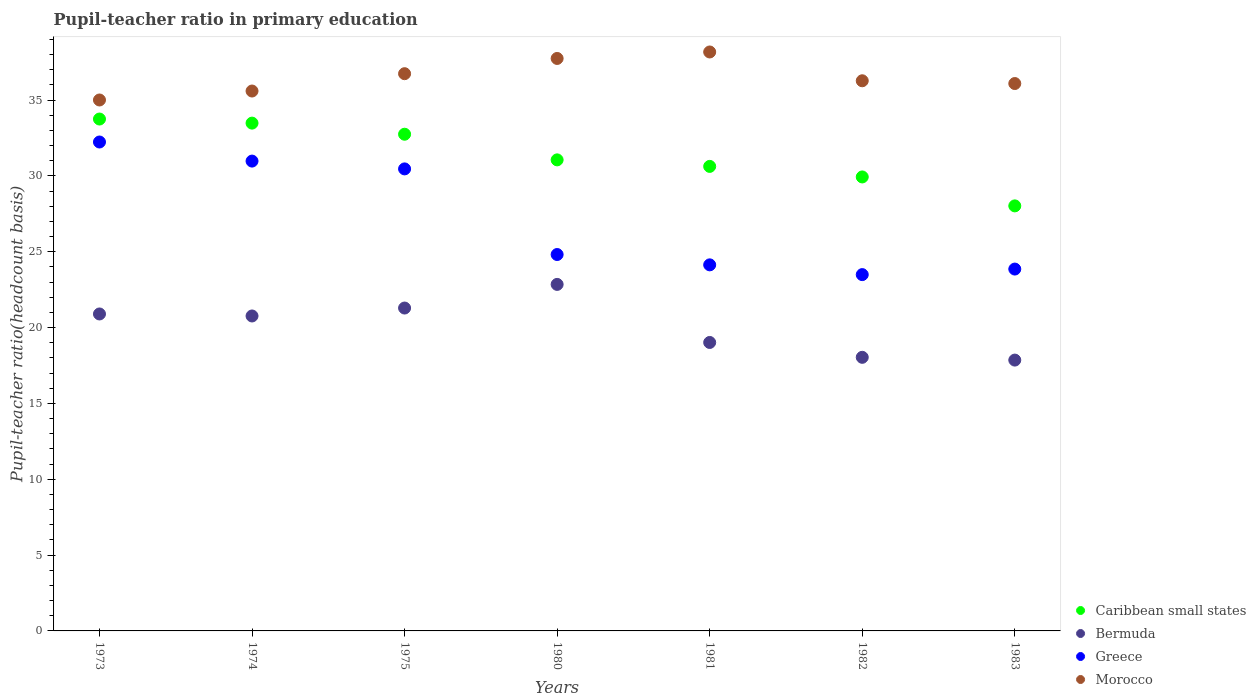What is the pupil-teacher ratio in primary education in Greece in 1981?
Keep it short and to the point. 24.14. Across all years, what is the maximum pupil-teacher ratio in primary education in Greece?
Your response must be concise. 32.24. Across all years, what is the minimum pupil-teacher ratio in primary education in Greece?
Your answer should be compact. 23.49. What is the total pupil-teacher ratio in primary education in Morocco in the graph?
Give a very brief answer. 255.63. What is the difference between the pupil-teacher ratio in primary education in Morocco in 1974 and that in 1982?
Your answer should be compact. -0.68. What is the difference between the pupil-teacher ratio in primary education in Greece in 1983 and the pupil-teacher ratio in primary education in Caribbean small states in 1980?
Make the answer very short. -7.2. What is the average pupil-teacher ratio in primary education in Greece per year?
Keep it short and to the point. 27.14. In the year 1981, what is the difference between the pupil-teacher ratio in primary education in Morocco and pupil-teacher ratio in primary education in Greece?
Give a very brief answer. 14.04. In how many years, is the pupil-teacher ratio in primary education in Greece greater than 20?
Offer a very short reply. 7. What is the ratio of the pupil-teacher ratio in primary education in Morocco in 1981 to that in 1982?
Ensure brevity in your answer.  1.05. What is the difference between the highest and the second highest pupil-teacher ratio in primary education in Greece?
Offer a very short reply. 1.26. What is the difference between the highest and the lowest pupil-teacher ratio in primary education in Morocco?
Your response must be concise. 3.17. In how many years, is the pupil-teacher ratio in primary education in Caribbean small states greater than the average pupil-teacher ratio in primary education in Caribbean small states taken over all years?
Offer a very short reply. 3. Is it the case that in every year, the sum of the pupil-teacher ratio in primary education in Morocco and pupil-teacher ratio in primary education in Caribbean small states  is greater than the sum of pupil-teacher ratio in primary education in Bermuda and pupil-teacher ratio in primary education in Greece?
Provide a succinct answer. Yes. Is it the case that in every year, the sum of the pupil-teacher ratio in primary education in Greece and pupil-teacher ratio in primary education in Bermuda  is greater than the pupil-teacher ratio in primary education in Caribbean small states?
Keep it short and to the point. Yes. Is the pupil-teacher ratio in primary education in Greece strictly greater than the pupil-teacher ratio in primary education in Bermuda over the years?
Ensure brevity in your answer.  Yes. How many years are there in the graph?
Ensure brevity in your answer.  7. Does the graph contain any zero values?
Keep it short and to the point. No. How many legend labels are there?
Your answer should be compact. 4. How are the legend labels stacked?
Your answer should be compact. Vertical. What is the title of the graph?
Provide a succinct answer. Pupil-teacher ratio in primary education. Does "Caribbean small states" appear as one of the legend labels in the graph?
Ensure brevity in your answer.  Yes. What is the label or title of the X-axis?
Give a very brief answer. Years. What is the label or title of the Y-axis?
Your answer should be very brief. Pupil-teacher ratio(headcount basis). What is the Pupil-teacher ratio(headcount basis) in Caribbean small states in 1973?
Give a very brief answer. 33.75. What is the Pupil-teacher ratio(headcount basis) of Bermuda in 1973?
Provide a succinct answer. 20.9. What is the Pupil-teacher ratio(headcount basis) of Greece in 1973?
Your answer should be compact. 32.24. What is the Pupil-teacher ratio(headcount basis) of Morocco in 1973?
Your answer should be very brief. 35.01. What is the Pupil-teacher ratio(headcount basis) in Caribbean small states in 1974?
Your answer should be very brief. 33.48. What is the Pupil-teacher ratio(headcount basis) of Bermuda in 1974?
Make the answer very short. 20.77. What is the Pupil-teacher ratio(headcount basis) of Greece in 1974?
Keep it short and to the point. 30.98. What is the Pupil-teacher ratio(headcount basis) of Morocco in 1974?
Offer a terse response. 35.6. What is the Pupil-teacher ratio(headcount basis) in Caribbean small states in 1975?
Your answer should be compact. 32.75. What is the Pupil-teacher ratio(headcount basis) of Bermuda in 1975?
Offer a very short reply. 21.29. What is the Pupil-teacher ratio(headcount basis) of Greece in 1975?
Give a very brief answer. 30.46. What is the Pupil-teacher ratio(headcount basis) of Morocco in 1975?
Give a very brief answer. 36.74. What is the Pupil-teacher ratio(headcount basis) in Caribbean small states in 1980?
Offer a very short reply. 31.06. What is the Pupil-teacher ratio(headcount basis) in Bermuda in 1980?
Give a very brief answer. 22.85. What is the Pupil-teacher ratio(headcount basis) of Greece in 1980?
Your answer should be compact. 24.82. What is the Pupil-teacher ratio(headcount basis) in Morocco in 1980?
Provide a short and direct response. 37.75. What is the Pupil-teacher ratio(headcount basis) in Caribbean small states in 1981?
Offer a very short reply. 30.63. What is the Pupil-teacher ratio(headcount basis) of Bermuda in 1981?
Provide a short and direct response. 19.02. What is the Pupil-teacher ratio(headcount basis) of Greece in 1981?
Provide a succinct answer. 24.14. What is the Pupil-teacher ratio(headcount basis) of Morocco in 1981?
Offer a very short reply. 38.17. What is the Pupil-teacher ratio(headcount basis) of Caribbean small states in 1982?
Provide a short and direct response. 29.93. What is the Pupil-teacher ratio(headcount basis) in Bermuda in 1982?
Your answer should be very brief. 18.04. What is the Pupil-teacher ratio(headcount basis) in Greece in 1982?
Ensure brevity in your answer.  23.49. What is the Pupil-teacher ratio(headcount basis) of Morocco in 1982?
Make the answer very short. 36.27. What is the Pupil-teacher ratio(headcount basis) in Caribbean small states in 1983?
Make the answer very short. 28.02. What is the Pupil-teacher ratio(headcount basis) of Bermuda in 1983?
Keep it short and to the point. 17.86. What is the Pupil-teacher ratio(headcount basis) of Greece in 1983?
Make the answer very short. 23.86. What is the Pupil-teacher ratio(headcount basis) of Morocco in 1983?
Provide a short and direct response. 36.09. Across all years, what is the maximum Pupil-teacher ratio(headcount basis) of Caribbean small states?
Your response must be concise. 33.75. Across all years, what is the maximum Pupil-teacher ratio(headcount basis) in Bermuda?
Give a very brief answer. 22.85. Across all years, what is the maximum Pupil-teacher ratio(headcount basis) of Greece?
Your response must be concise. 32.24. Across all years, what is the maximum Pupil-teacher ratio(headcount basis) of Morocco?
Offer a terse response. 38.17. Across all years, what is the minimum Pupil-teacher ratio(headcount basis) of Caribbean small states?
Your answer should be very brief. 28.02. Across all years, what is the minimum Pupil-teacher ratio(headcount basis) of Bermuda?
Provide a succinct answer. 17.86. Across all years, what is the minimum Pupil-teacher ratio(headcount basis) of Greece?
Give a very brief answer. 23.49. Across all years, what is the minimum Pupil-teacher ratio(headcount basis) of Morocco?
Offer a terse response. 35.01. What is the total Pupil-teacher ratio(headcount basis) of Caribbean small states in the graph?
Your answer should be very brief. 219.62. What is the total Pupil-teacher ratio(headcount basis) of Bermuda in the graph?
Provide a short and direct response. 140.72. What is the total Pupil-teacher ratio(headcount basis) of Greece in the graph?
Offer a terse response. 189.98. What is the total Pupil-teacher ratio(headcount basis) in Morocco in the graph?
Offer a very short reply. 255.63. What is the difference between the Pupil-teacher ratio(headcount basis) of Caribbean small states in 1973 and that in 1974?
Give a very brief answer. 0.27. What is the difference between the Pupil-teacher ratio(headcount basis) of Bermuda in 1973 and that in 1974?
Keep it short and to the point. 0.13. What is the difference between the Pupil-teacher ratio(headcount basis) of Greece in 1973 and that in 1974?
Provide a succinct answer. 1.26. What is the difference between the Pupil-teacher ratio(headcount basis) in Morocco in 1973 and that in 1974?
Ensure brevity in your answer.  -0.59. What is the difference between the Pupil-teacher ratio(headcount basis) in Caribbean small states in 1973 and that in 1975?
Keep it short and to the point. 1. What is the difference between the Pupil-teacher ratio(headcount basis) in Bermuda in 1973 and that in 1975?
Your answer should be compact. -0.39. What is the difference between the Pupil-teacher ratio(headcount basis) of Greece in 1973 and that in 1975?
Your answer should be compact. 1.77. What is the difference between the Pupil-teacher ratio(headcount basis) of Morocco in 1973 and that in 1975?
Provide a succinct answer. -1.73. What is the difference between the Pupil-teacher ratio(headcount basis) of Caribbean small states in 1973 and that in 1980?
Provide a succinct answer. 2.69. What is the difference between the Pupil-teacher ratio(headcount basis) of Bermuda in 1973 and that in 1980?
Provide a short and direct response. -1.95. What is the difference between the Pupil-teacher ratio(headcount basis) in Greece in 1973 and that in 1980?
Give a very brief answer. 7.42. What is the difference between the Pupil-teacher ratio(headcount basis) of Morocco in 1973 and that in 1980?
Give a very brief answer. -2.74. What is the difference between the Pupil-teacher ratio(headcount basis) in Caribbean small states in 1973 and that in 1981?
Make the answer very short. 3.12. What is the difference between the Pupil-teacher ratio(headcount basis) of Bermuda in 1973 and that in 1981?
Make the answer very short. 1.88. What is the difference between the Pupil-teacher ratio(headcount basis) in Greece in 1973 and that in 1981?
Ensure brevity in your answer.  8.1. What is the difference between the Pupil-teacher ratio(headcount basis) of Morocco in 1973 and that in 1981?
Provide a succinct answer. -3.17. What is the difference between the Pupil-teacher ratio(headcount basis) of Caribbean small states in 1973 and that in 1982?
Provide a succinct answer. 3.82. What is the difference between the Pupil-teacher ratio(headcount basis) in Bermuda in 1973 and that in 1982?
Your response must be concise. 2.86. What is the difference between the Pupil-teacher ratio(headcount basis) in Greece in 1973 and that in 1982?
Provide a short and direct response. 8.74. What is the difference between the Pupil-teacher ratio(headcount basis) in Morocco in 1973 and that in 1982?
Keep it short and to the point. -1.27. What is the difference between the Pupil-teacher ratio(headcount basis) of Caribbean small states in 1973 and that in 1983?
Your answer should be compact. 5.73. What is the difference between the Pupil-teacher ratio(headcount basis) of Bermuda in 1973 and that in 1983?
Make the answer very short. 3.04. What is the difference between the Pupil-teacher ratio(headcount basis) of Greece in 1973 and that in 1983?
Provide a short and direct response. 8.38. What is the difference between the Pupil-teacher ratio(headcount basis) in Morocco in 1973 and that in 1983?
Give a very brief answer. -1.08. What is the difference between the Pupil-teacher ratio(headcount basis) in Caribbean small states in 1974 and that in 1975?
Ensure brevity in your answer.  0.73. What is the difference between the Pupil-teacher ratio(headcount basis) in Bermuda in 1974 and that in 1975?
Ensure brevity in your answer.  -0.52. What is the difference between the Pupil-teacher ratio(headcount basis) in Greece in 1974 and that in 1975?
Make the answer very short. 0.51. What is the difference between the Pupil-teacher ratio(headcount basis) of Morocco in 1974 and that in 1975?
Keep it short and to the point. -1.14. What is the difference between the Pupil-teacher ratio(headcount basis) of Caribbean small states in 1974 and that in 1980?
Your answer should be very brief. 2.42. What is the difference between the Pupil-teacher ratio(headcount basis) in Bermuda in 1974 and that in 1980?
Provide a short and direct response. -2.08. What is the difference between the Pupil-teacher ratio(headcount basis) of Greece in 1974 and that in 1980?
Your answer should be very brief. 6.16. What is the difference between the Pupil-teacher ratio(headcount basis) of Morocco in 1974 and that in 1980?
Ensure brevity in your answer.  -2.15. What is the difference between the Pupil-teacher ratio(headcount basis) of Caribbean small states in 1974 and that in 1981?
Ensure brevity in your answer.  2.85. What is the difference between the Pupil-teacher ratio(headcount basis) of Bermuda in 1974 and that in 1981?
Provide a short and direct response. 1.75. What is the difference between the Pupil-teacher ratio(headcount basis) of Greece in 1974 and that in 1981?
Your answer should be very brief. 6.84. What is the difference between the Pupil-teacher ratio(headcount basis) in Morocco in 1974 and that in 1981?
Keep it short and to the point. -2.57. What is the difference between the Pupil-teacher ratio(headcount basis) of Caribbean small states in 1974 and that in 1982?
Your response must be concise. 3.55. What is the difference between the Pupil-teacher ratio(headcount basis) of Bermuda in 1974 and that in 1982?
Provide a short and direct response. 2.73. What is the difference between the Pupil-teacher ratio(headcount basis) of Greece in 1974 and that in 1982?
Give a very brief answer. 7.48. What is the difference between the Pupil-teacher ratio(headcount basis) in Morocco in 1974 and that in 1982?
Your response must be concise. -0.68. What is the difference between the Pupil-teacher ratio(headcount basis) of Caribbean small states in 1974 and that in 1983?
Your response must be concise. 5.46. What is the difference between the Pupil-teacher ratio(headcount basis) of Bermuda in 1974 and that in 1983?
Offer a terse response. 2.91. What is the difference between the Pupil-teacher ratio(headcount basis) of Greece in 1974 and that in 1983?
Provide a short and direct response. 7.12. What is the difference between the Pupil-teacher ratio(headcount basis) of Morocco in 1974 and that in 1983?
Make the answer very short. -0.49. What is the difference between the Pupil-teacher ratio(headcount basis) of Caribbean small states in 1975 and that in 1980?
Make the answer very short. 1.69. What is the difference between the Pupil-teacher ratio(headcount basis) of Bermuda in 1975 and that in 1980?
Your response must be concise. -1.56. What is the difference between the Pupil-teacher ratio(headcount basis) of Greece in 1975 and that in 1980?
Give a very brief answer. 5.65. What is the difference between the Pupil-teacher ratio(headcount basis) in Morocco in 1975 and that in 1980?
Provide a succinct answer. -1. What is the difference between the Pupil-teacher ratio(headcount basis) of Caribbean small states in 1975 and that in 1981?
Ensure brevity in your answer.  2.12. What is the difference between the Pupil-teacher ratio(headcount basis) of Bermuda in 1975 and that in 1981?
Provide a succinct answer. 2.27. What is the difference between the Pupil-teacher ratio(headcount basis) of Greece in 1975 and that in 1981?
Your answer should be compact. 6.33. What is the difference between the Pupil-teacher ratio(headcount basis) in Morocco in 1975 and that in 1981?
Offer a very short reply. -1.43. What is the difference between the Pupil-teacher ratio(headcount basis) of Caribbean small states in 1975 and that in 1982?
Offer a terse response. 2.82. What is the difference between the Pupil-teacher ratio(headcount basis) in Bermuda in 1975 and that in 1982?
Your answer should be very brief. 3.25. What is the difference between the Pupil-teacher ratio(headcount basis) in Greece in 1975 and that in 1982?
Provide a short and direct response. 6.97. What is the difference between the Pupil-teacher ratio(headcount basis) of Morocco in 1975 and that in 1982?
Offer a terse response. 0.47. What is the difference between the Pupil-teacher ratio(headcount basis) in Caribbean small states in 1975 and that in 1983?
Offer a very short reply. 4.72. What is the difference between the Pupil-teacher ratio(headcount basis) in Bermuda in 1975 and that in 1983?
Offer a very short reply. 3.43. What is the difference between the Pupil-teacher ratio(headcount basis) in Greece in 1975 and that in 1983?
Give a very brief answer. 6.6. What is the difference between the Pupil-teacher ratio(headcount basis) in Morocco in 1975 and that in 1983?
Provide a short and direct response. 0.65. What is the difference between the Pupil-teacher ratio(headcount basis) in Caribbean small states in 1980 and that in 1981?
Ensure brevity in your answer.  0.43. What is the difference between the Pupil-teacher ratio(headcount basis) of Bermuda in 1980 and that in 1981?
Give a very brief answer. 3.83. What is the difference between the Pupil-teacher ratio(headcount basis) in Greece in 1980 and that in 1981?
Provide a short and direct response. 0.68. What is the difference between the Pupil-teacher ratio(headcount basis) of Morocco in 1980 and that in 1981?
Your answer should be very brief. -0.43. What is the difference between the Pupil-teacher ratio(headcount basis) of Caribbean small states in 1980 and that in 1982?
Give a very brief answer. 1.13. What is the difference between the Pupil-teacher ratio(headcount basis) in Bermuda in 1980 and that in 1982?
Give a very brief answer. 4.81. What is the difference between the Pupil-teacher ratio(headcount basis) in Greece in 1980 and that in 1982?
Provide a succinct answer. 1.32. What is the difference between the Pupil-teacher ratio(headcount basis) in Morocco in 1980 and that in 1982?
Offer a very short reply. 1.47. What is the difference between the Pupil-teacher ratio(headcount basis) of Caribbean small states in 1980 and that in 1983?
Offer a terse response. 3.03. What is the difference between the Pupil-teacher ratio(headcount basis) of Bermuda in 1980 and that in 1983?
Ensure brevity in your answer.  4.99. What is the difference between the Pupil-teacher ratio(headcount basis) of Greece in 1980 and that in 1983?
Provide a short and direct response. 0.96. What is the difference between the Pupil-teacher ratio(headcount basis) in Morocco in 1980 and that in 1983?
Offer a very short reply. 1.65. What is the difference between the Pupil-teacher ratio(headcount basis) in Caribbean small states in 1981 and that in 1982?
Your answer should be compact. 0.7. What is the difference between the Pupil-teacher ratio(headcount basis) of Bermuda in 1981 and that in 1982?
Your answer should be very brief. 0.98. What is the difference between the Pupil-teacher ratio(headcount basis) in Greece in 1981 and that in 1982?
Make the answer very short. 0.64. What is the difference between the Pupil-teacher ratio(headcount basis) in Morocco in 1981 and that in 1982?
Provide a short and direct response. 1.9. What is the difference between the Pupil-teacher ratio(headcount basis) of Caribbean small states in 1981 and that in 1983?
Ensure brevity in your answer.  2.6. What is the difference between the Pupil-teacher ratio(headcount basis) of Bermuda in 1981 and that in 1983?
Provide a succinct answer. 1.16. What is the difference between the Pupil-teacher ratio(headcount basis) of Greece in 1981 and that in 1983?
Your answer should be compact. 0.28. What is the difference between the Pupil-teacher ratio(headcount basis) in Morocco in 1981 and that in 1983?
Your response must be concise. 2.08. What is the difference between the Pupil-teacher ratio(headcount basis) in Caribbean small states in 1982 and that in 1983?
Offer a very short reply. 1.91. What is the difference between the Pupil-teacher ratio(headcount basis) in Bermuda in 1982 and that in 1983?
Offer a terse response. 0.18. What is the difference between the Pupil-teacher ratio(headcount basis) of Greece in 1982 and that in 1983?
Keep it short and to the point. -0.37. What is the difference between the Pupil-teacher ratio(headcount basis) of Morocco in 1982 and that in 1983?
Your answer should be compact. 0.18. What is the difference between the Pupil-teacher ratio(headcount basis) of Caribbean small states in 1973 and the Pupil-teacher ratio(headcount basis) of Bermuda in 1974?
Offer a very short reply. 12.98. What is the difference between the Pupil-teacher ratio(headcount basis) in Caribbean small states in 1973 and the Pupil-teacher ratio(headcount basis) in Greece in 1974?
Provide a succinct answer. 2.77. What is the difference between the Pupil-teacher ratio(headcount basis) in Caribbean small states in 1973 and the Pupil-teacher ratio(headcount basis) in Morocco in 1974?
Ensure brevity in your answer.  -1.85. What is the difference between the Pupil-teacher ratio(headcount basis) of Bermuda in 1973 and the Pupil-teacher ratio(headcount basis) of Greece in 1974?
Your response must be concise. -10.08. What is the difference between the Pupil-teacher ratio(headcount basis) in Bermuda in 1973 and the Pupil-teacher ratio(headcount basis) in Morocco in 1974?
Provide a succinct answer. -14.7. What is the difference between the Pupil-teacher ratio(headcount basis) of Greece in 1973 and the Pupil-teacher ratio(headcount basis) of Morocco in 1974?
Your response must be concise. -3.36. What is the difference between the Pupil-teacher ratio(headcount basis) in Caribbean small states in 1973 and the Pupil-teacher ratio(headcount basis) in Bermuda in 1975?
Offer a terse response. 12.46. What is the difference between the Pupil-teacher ratio(headcount basis) in Caribbean small states in 1973 and the Pupil-teacher ratio(headcount basis) in Greece in 1975?
Make the answer very short. 3.29. What is the difference between the Pupil-teacher ratio(headcount basis) of Caribbean small states in 1973 and the Pupil-teacher ratio(headcount basis) of Morocco in 1975?
Give a very brief answer. -2.99. What is the difference between the Pupil-teacher ratio(headcount basis) in Bermuda in 1973 and the Pupil-teacher ratio(headcount basis) in Greece in 1975?
Your answer should be very brief. -9.56. What is the difference between the Pupil-teacher ratio(headcount basis) in Bermuda in 1973 and the Pupil-teacher ratio(headcount basis) in Morocco in 1975?
Offer a very short reply. -15.84. What is the difference between the Pupil-teacher ratio(headcount basis) in Greece in 1973 and the Pupil-teacher ratio(headcount basis) in Morocco in 1975?
Provide a short and direct response. -4.5. What is the difference between the Pupil-teacher ratio(headcount basis) of Caribbean small states in 1973 and the Pupil-teacher ratio(headcount basis) of Bermuda in 1980?
Keep it short and to the point. 10.9. What is the difference between the Pupil-teacher ratio(headcount basis) of Caribbean small states in 1973 and the Pupil-teacher ratio(headcount basis) of Greece in 1980?
Your answer should be compact. 8.93. What is the difference between the Pupil-teacher ratio(headcount basis) of Caribbean small states in 1973 and the Pupil-teacher ratio(headcount basis) of Morocco in 1980?
Your answer should be compact. -3.99. What is the difference between the Pupil-teacher ratio(headcount basis) of Bermuda in 1973 and the Pupil-teacher ratio(headcount basis) of Greece in 1980?
Offer a terse response. -3.92. What is the difference between the Pupil-teacher ratio(headcount basis) in Bermuda in 1973 and the Pupil-teacher ratio(headcount basis) in Morocco in 1980?
Ensure brevity in your answer.  -16.85. What is the difference between the Pupil-teacher ratio(headcount basis) in Greece in 1973 and the Pupil-teacher ratio(headcount basis) in Morocco in 1980?
Make the answer very short. -5.51. What is the difference between the Pupil-teacher ratio(headcount basis) of Caribbean small states in 1973 and the Pupil-teacher ratio(headcount basis) of Bermuda in 1981?
Keep it short and to the point. 14.73. What is the difference between the Pupil-teacher ratio(headcount basis) of Caribbean small states in 1973 and the Pupil-teacher ratio(headcount basis) of Greece in 1981?
Keep it short and to the point. 9.61. What is the difference between the Pupil-teacher ratio(headcount basis) of Caribbean small states in 1973 and the Pupil-teacher ratio(headcount basis) of Morocco in 1981?
Your answer should be compact. -4.42. What is the difference between the Pupil-teacher ratio(headcount basis) in Bermuda in 1973 and the Pupil-teacher ratio(headcount basis) in Greece in 1981?
Your response must be concise. -3.24. What is the difference between the Pupil-teacher ratio(headcount basis) of Bermuda in 1973 and the Pupil-teacher ratio(headcount basis) of Morocco in 1981?
Provide a succinct answer. -17.27. What is the difference between the Pupil-teacher ratio(headcount basis) of Greece in 1973 and the Pupil-teacher ratio(headcount basis) of Morocco in 1981?
Provide a succinct answer. -5.94. What is the difference between the Pupil-teacher ratio(headcount basis) in Caribbean small states in 1973 and the Pupil-teacher ratio(headcount basis) in Bermuda in 1982?
Make the answer very short. 15.71. What is the difference between the Pupil-teacher ratio(headcount basis) in Caribbean small states in 1973 and the Pupil-teacher ratio(headcount basis) in Greece in 1982?
Provide a succinct answer. 10.26. What is the difference between the Pupil-teacher ratio(headcount basis) in Caribbean small states in 1973 and the Pupil-teacher ratio(headcount basis) in Morocco in 1982?
Give a very brief answer. -2.52. What is the difference between the Pupil-teacher ratio(headcount basis) in Bermuda in 1973 and the Pupil-teacher ratio(headcount basis) in Greece in 1982?
Provide a succinct answer. -2.59. What is the difference between the Pupil-teacher ratio(headcount basis) of Bermuda in 1973 and the Pupil-teacher ratio(headcount basis) of Morocco in 1982?
Offer a terse response. -15.37. What is the difference between the Pupil-teacher ratio(headcount basis) of Greece in 1973 and the Pupil-teacher ratio(headcount basis) of Morocco in 1982?
Keep it short and to the point. -4.04. What is the difference between the Pupil-teacher ratio(headcount basis) in Caribbean small states in 1973 and the Pupil-teacher ratio(headcount basis) in Bermuda in 1983?
Your answer should be very brief. 15.89. What is the difference between the Pupil-teacher ratio(headcount basis) in Caribbean small states in 1973 and the Pupil-teacher ratio(headcount basis) in Greece in 1983?
Provide a short and direct response. 9.89. What is the difference between the Pupil-teacher ratio(headcount basis) of Caribbean small states in 1973 and the Pupil-teacher ratio(headcount basis) of Morocco in 1983?
Ensure brevity in your answer.  -2.34. What is the difference between the Pupil-teacher ratio(headcount basis) of Bermuda in 1973 and the Pupil-teacher ratio(headcount basis) of Greece in 1983?
Offer a terse response. -2.96. What is the difference between the Pupil-teacher ratio(headcount basis) of Bermuda in 1973 and the Pupil-teacher ratio(headcount basis) of Morocco in 1983?
Make the answer very short. -15.19. What is the difference between the Pupil-teacher ratio(headcount basis) of Greece in 1973 and the Pupil-teacher ratio(headcount basis) of Morocco in 1983?
Provide a succinct answer. -3.86. What is the difference between the Pupil-teacher ratio(headcount basis) in Caribbean small states in 1974 and the Pupil-teacher ratio(headcount basis) in Bermuda in 1975?
Give a very brief answer. 12.19. What is the difference between the Pupil-teacher ratio(headcount basis) of Caribbean small states in 1974 and the Pupil-teacher ratio(headcount basis) of Greece in 1975?
Provide a short and direct response. 3.02. What is the difference between the Pupil-teacher ratio(headcount basis) of Caribbean small states in 1974 and the Pupil-teacher ratio(headcount basis) of Morocco in 1975?
Make the answer very short. -3.26. What is the difference between the Pupil-teacher ratio(headcount basis) of Bermuda in 1974 and the Pupil-teacher ratio(headcount basis) of Greece in 1975?
Your answer should be very brief. -9.7. What is the difference between the Pupil-teacher ratio(headcount basis) of Bermuda in 1974 and the Pupil-teacher ratio(headcount basis) of Morocco in 1975?
Your answer should be compact. -15.97. What is the difference between the Pupil-teacher ratio(headcount basis) of Greece in 1974 and the Pupil-teacher ratio(headcount basis) of Morocco in 1975?
Your response must be concise. -5.76. What is the difference between the Pupil-teacher ratio(headcount basis) of Caribbean small states in 1974 and the Pupil-teacher ratio(headcount basis) of Bermuda in 1980?
Make the answer very short. 10.63. What is the difference between the Pupil-teacher ratio(headcount basis) in Caribbean small states in 1974 and the Pupil-teacher ratio(headcount basis) in Greece in 1980?
Give a very brief answer. 8.66. What is the difference between the Pupil-teacher ratio(headcount basis) in Caribbean small states in 1974 and the Pupil-teacher ratio(headcount basis) in Morocco in 1980?
Make the answer very short. -4.26. What is the difference between the Pupil-teacher ratio(headcount basis) of Bermuda in 1974 and the Pupil-teacher ratio(headcount basis) of Greece in 1980?
Provide a short and direct response. -4.05. What is the difference between the Pupil-teacher ratio(headcount basis) in Bermuda in 1974 and the Pupil-teacher ratio(headcount basis) in Morocco in 1980?
Your response must be concise. -16.98. What is the difference between the Pupil-teacher ratio(headcount basis) in Greece in 1974 and the Pupil-teacher ratio(headcount basis) in Morocco in 1980?
Your response must be concise. -6.77. What is the difference between the Pupil-teacher ratio(headcount basis) of Caribbean small states in 1974 and the Pupil-teacher ratio(headcount basis) of Bermuda in 1981?
Provide a short and direct response. 14.46. What is the difference between the Pupil-teacher ratio(headcount basis) in Caribbean small states in 1974 and the Pupil-teacher ratio(headcount basis) in Greece in 1981?
Your answer should be very brief. 9.35. What is the difference between the Pupil-teacher ratio(headcount basis) of Caribbean small states in 1974 and the Pupil-teacher ratio(headcount basis) of Morocco in 1981?
Ensure brevity in your answer.  -4.69. What is the difference between the Pupil-teacher ratio(headcount basis) in Bermuda in 1974 and the Pupil-teacher ratio(headcount basis) in Greece in 1981?
Your response must be concise. -3.37. What is the difference between the Pupil-teacher ratio(headcount basis) of Bermuda in 1974 and the Pupil-teacher ratio(headcount basis) of Morocco in 1981?
Your answer should be compact. -17.41. What is the difference between the Pupil-teacher ratio(headcount basis) of Greece in 1974 and the Pupil-teacher ratio(headcount basis) of Morocco in 1981?
Offer a very short reply. -7.19. What is the difference between the Pupil-teacher ratio(headcount basis) of Caribbean small states in 1974 and the Pupil-teacher ratio(headcount basis) of Bermuda in 1982?
Your response must be concise. 15.44. What is the difference between the Pupil-teacher ratio(headcount basis) of Caribbean small states in 1974 and the Pupil-teacher ratio(headcount basis) of Greece in 1982?
Offer a terse response. 9.99. What is the difference between the Pupil-teacher ratio(headcount basis) in Caribbean small states in 1974 and the Pupil-teacher ratio(headcount basis) in Morocco in 1982?
Offer a terse response. -2.79. What is the difference between the Pupil-teacher ratio(headcount basis) of Bermuda in 1974 and the Pupil-teacher ratio(headcount basis) of Greece in 1982?
Give a very brief answer. -2.73. What is the difference between the Pupil-teacher ratio(headcount basis) of Bermuda in 1974 and the Pupil-teacher ratio(headcount basis) of Morocco in 1982?
Your response must be concise. -15.51. What is the difference between the Pupil-teacher ratio(headcount basis) of Greece in 1974 and the Pupil-teacher ratio(headcount basis) of Morocco in 1982?
Keep it short and to the point. -5.3. What is the difference between the Pupil-teacher ratio(headcount basis) of Caribbean small states in 1974 and the Pupil-teacher ratio(headcount basis) of Bermuda in 1983?
Make the answer very short. 15.62. What is the difference between the Pupil-teacher ratio(headcount basis) in Caribbean small states in 1974 and the Pupil-teacher ratio(headcount basis) in Greece in 1983?
Your answer should be compact. 9.62. What is the difference between the Pupil-teacher ratio(headcount basis) in Caribbean small states in 1974 and the Pupil-teacher ratio(headcount basis) in Morocco in 1983?
Offer a terse response. -2.61. What is the difference between the Pupil-teacher ratio(headcount basis) in Bermuda in 1974 and the Pupil-teacher ratio(headcount basis) in Greece in 1983?
Your answer should be compact. -3.09. What is the difference between the Pupil-teacher ratio(headcount basis) in Bermuda in 1974 and the Pupil-teacher ratio(headcount basis) in Morocco in 1983?
Make the answer very short. -15.33. What is the difference between the Pupil-teacher ratio(headcount basis) in Greece in 1974 and the Pupil-teacher ratio(headcount basis) in Morocco in 1983?
Your answer should be compact. -5.11. What is the difference between the Pupil-teacher ratio(headcount basis) of Caribbean small states in 1975 and the Pupil-teacher ratio(headcount basis) of Bermuda in 1980?
Offer a very short reply. 9.9. What is the difference between the Pupil-teacher ratio(headcount basis) in Caribbean small states in 1975 and the Pupil-teacher ratio(headcount basis) in Greece in 1980?
Provide a short and direct response. 7.93. What is the difference between the Pupil-teacher ratio(headcount basis) of Caribbean small states in 1975 and the Pupil-teacher ratio(headcount basis) of Morocco in 1980?
Keep it short and to the point. -5. What is the difference between the Pupil-teacher ratio(headcount basis) in Bermuda in 1975 and the Pupil-teacher ratio(headcount basis) in Greece in 1980?
Your answer should be compact. -3.53. What is the difference between the Pupil-teacher ratio(headcount basis) in Bermuda in 1975 and the Pupil-teacher ratio(headcount basis) in Morocco in 1980?
Your response must be concise. -16.46. What is the difference between the Pupil-teacher ratio(headcount basis) of Greece in 1975 and the Pupil-teacher ratio(headcount basis) of Morocco in 1980?
Your answer should be compact. -7.28. What is the difference between the Pupil-teacher ratio(headcount basis) of Caribbean small states in 1975 and the Pupil-teacher ratio(headcount basis) of Bermuda in 1981?
Make the answer very short. 13.73. What is the difference between the Pupil-teacher ratio(headcount basis) in Caribbean small states in 1975 and the Pupil-teacher ratio(headcount basis) in Greece in 1981?
Make the answer very short. 8.61. What is the difference between the Pupil-teacher ratio(headcount basis) in Caribbean small states in 1975 and the Pupil-teacher ratio(headcount basis) in Morocco in 1981?
Provide a succinct answer. -5.42. What is the difference between the Pupil-teacher ratio(headcount basis) in Bermuda in 1975 and the Pupil-teacher ratio(headcount basis) in Greece in 1981?
Offer a terse response. -2.85. What is the difference between the Pupil-teacher ratio(headcount basis) in Bermuda in 1975 and the Pupil-teacher ratio(headcount basis) in Morocco in 1981?
Make the answer very short. -16.88. What is the difference between the Pupil-teacher ratio(headcount basis) of Greece in 1975 and the Pupil-teacher ratio(headcount basis) of Morocco in 1981?
Your answer should be very brief. -7.71. What is the difference between the Pupil-teacher ratio(headcount basis) in Caribbean small states in 1975 and the Pupil-teacher ratio(headcount basis) in Bermuda in 1982?
Offer a terse response. 14.71. What is the difference between the Pupil-teacher ratio(headcount basis) of Caribbean small states in 1975 and the Pupil-teacher ratio(headcount basis) of Greece in 1982?
Your response must be concise. 9.26. What is the difference between the Pupil-teacher ratio(headcount basis) in Caribbean small states in 1975 and the Pupil-teacher ratio(headcount basis) in Morocco in 1982?
Ensure brevity in your answer.  -3.52. What is the difference between the Pupil-teacher ratio(headcount basis) in Bermuda in 1975 and the Pupil-teacher ratio(headcount basis) in Greece in 1982?
Offer a terse response. -2.2. What is the difference between the Pupil-teacher ratio(headcount basis) of Bermuda in 1975 and the Pupil-teacher ratio(headcount basis) of Morocco in 1982?
Provide a short and direct response. -14.98. What is the difference between the Pupil-teacher ratio(headcount basis) in Greece in 1975 and the Pupil-teacher ratio(headcount basis) in Morocco in 1982?
Make the answer very short. -5.81. What is the difference between the Pupil-teacher ratio(headcount basis) in Caribbean small states in 1975 and the Pupil-teacher ratio(headcount basis) in Bermuda in 1983?
Provide a succinct answer. 14.89. What is the difference between the Pupil-teacher ratio(headcount basis) of Caribbean small states in 1975 and the Pupil-teacher ratio(headcount basis) of Greece in 1983?
Your answer should be very brief. 8.89. What is the difference between the Pupil-teacher ratio(headcount basis) in Caribbean small states in 1975 and the Pupil-teacher ratio(headcount basis) in Morocco in 1983?
Provide a succinct answer. -3.34. What is the difference between the Pupil-teacher ratio(headcount basis) in Bermuda in 1975 and the Pupil-teacher ratio(headcount basis) in Greece in 1983?
Offer a terse response. -2.57. What is the difference between the Pupil-teacher ratio(headcount basis) of Bermuda in 1975 and the Pupil-teacher ratio(headcount basis) of Morocco in 1983?
Your answer should be very brief. -14.8. What is the difference between the Pupil-teacher ratio(headcount basis) of Greece in 1975 and the Pupil-teacher ratio(headcount basis) of Morocco in 1983?
Keep it short and to the point. -5.63. What is the difference between the Pupil-teacher ratio(headcount basis) in Caribbean small states in 1980 and the Pupil-teacher ratio(headcount basis) in Bermuda in 1981?
Provide a succinct answer. 12.04. What is the difference between the Pupil-teacher ratio(headcount basis) in Caribbean small states in 1980 and the Pupil-teacher ratio(headcount basis) in Greece in 1981?
Your response must be concise. 6.92. What is the difference between the Pupil-teacher ratio(headcount basis) in Caribbean small states in 1980 and the Pupil-teacher ratio(headcount basis) in Morocco in 1981?
Keep it short and to the point. -7.11. What is the difference between the Pupil-teacher ratio(headcount basis) of Bermuda in 1980 and the Pupil-teacher ratio(headcount basis) of Greece in 1981?
Provide a short and direct response. -1.29. What is the difference between the Pupil-teacher ratio(headcount basis) of Bermuda in 1980 and the Pupil-teacher ratio(headcount basis) of Morocco in 1981?
Offer a very short reply. -15.32. What is the difference between the Pupil-teacher ratio(headcount basis) in Greece in 1980 and the Pupil-teacher ratio(headcount basis) in Morocco in 1981?
Give a very brief answer. -13.35. What is the difference between the Pupil-teacher ratio(headcount basis) of Caribbean small states in 1980 and the Pupil-teacher ratio(headcount basis) of Bermuda in 1982?
Your answer should be compact. 13.02. What is the difference between the Pupil-teacher ratio(headcount basis) of Caribbean small states in 1980 and the Pupil-teacher ratio(headcount basis) of Greece in 1982?
Your answer should be compact. 7.57. What is the difference between the Pupil-teacher ratio(headcount basis) of Caribbean small states in 1980 and the Pupil-teacher ratio(headcount basis) of Morocco in 1982?
Ensure brevity in your answer.  -5.22. What is the difference between the Pupil-teacher ratio(headcount basis) of Bermuda in 1980 and the Pupil-teacher ratio(headcount basis) of Greece in 1982?
Make the answer very short. -0.65. What is the difference between the Pupil-teacher ratio(headcount basis) in Bermuda in 1980 and the Pupil-teacher ratio(headcount basis) in Morocco in 1982?
Ensure brevity in your answer.  -13.43. What is the difference between the Pupil-teacher ratio(headcount basis) of Greece in 1980 and the Pupil-teacher ratio(headcount basis) of Morocco in 1982?
Ensure brevity in your answer.  -11.46. What is the difference between the Pupil-teacher ratio(headcount basis) in Caribbean small states in 1980 and the Pupil-teacher ratio(headcount basis) in Bermuda in 1983?
Ensure brevity in your answer.  13.2. What is the difference between the Pupil-teacher ratio(headcount basis) in Caribbean small states in 1980 and the Pupil-teacher ratio(headcount basis) in Greece in 1983?
Ensure brevity in your answer.  7.2. What is the difference between the Pupil-teacher ratio(headcount basis) of Caribbean small states in 1980 and the Pupil-teacher ratio(headcount basis) of Morocco in 1983?
Keep it short and to the point. -5.03. What is the difference between the Pupil-teacher ratio(headcount basis) of Bermuda in 1980 and the Pupil-teacher ratio(headcount basis) of Greece in 1983?
Keep it short and to the point. -1.01. What is the difference between the Pupil-teacher ratio(headcount basis) in Bermuda in 1980 and the Pupil-teacher ratio(headcount basis) in Morocco in 1983?
Your response must be concise. -13.24. What is the difference between the Pupil-teacher ratio(headcount basis) in Greece in 1980 and the Pupil-teacher ratio(headcount basis) in Morocco in 1983?
Ensure brevity in your answer.  -11.27. What is the difference between the Pupil-teacher ratio(headcount basis) in Caribbean small states in 1981 and the Pupil-teacher ratio(headcount basis) in Bermuda in 1982?
Provide a short and direct response. 12.59. What is the difference between the Pupil-teacher ratio(headcount basis) in Caribbean small states in 1981 and the Pupil-teacher ratio(headcount basis) in Greece in 1982?
Ensure brevity in your answer.  7.14. What is the difference between the Pupil-teacher ratio(headcount basis) of Caribbean small states in 1981 and the Pupil-teacher ratio(headcount basis) of Morocco in 1982?
Offer a terse response. -5.65. What is the difference between the Pupil-teacher ratio(headcount basis) in Bermuda in 1981 and the Pupil-teacher ratio(headcount basis) in Greece in 1982?
Give a very brief answer. -4.47. What is the difference between the Pupil-teacher ratio(headcount basis) of Bermuda in 1981 and the Pupil-teacher ratio(headcount basis) of Morocco in 1982?
Your response must be concise. -17.25. What is the difference between the Pupil-teacher ratio(headcount basis) in Greece in 1981 and the Pupil-teacher ratio(headcount basis) in Morocco in 1982?
Your response must be concise. -12.14. What is the difference between the Pupil-teacher ratio(headcount basis) in Caribbean small states in 1981 and the Pupil-teacher ratio(headcount basis) in Bermuda in 1983?
Your answer should be very brief. 12.77. What is the difference between the Pupil-teacher ratio(headcount basis) in Caribbean small states in 1981 and the Pupil-teacher ratio(headcount basis) in Greece in 1983?
Your answer should be compact. 6.77. What is the difference between the Pupil-teacher ratio(headcount basis) in Caribbean small states in 1981 and the Pupil-teacher ratio(headcount basis) in Morocco in 1983?
Ensure brevity in your answer.  -5.46. What is the difference between the Pupil-teacher ratio(headcount basis) in Bermuda in 1981 and the Pupil-teacher ratio(headcount basis) in Greece in 1983?
Keep it short and to the point. -4.84. What is the difference between the Pupil-teacher ratio(headcount basis) of Bermuda in 1981 and the Pupil-teacher ratio(headcount basis) of Morocco in 1983?
Your answer should be compact. -17.07. What is the difference between the Pupil-teacher ratio(headcount basis) in Greece in 1981 and the Pupil-teacher ratio(headcount basis) in Morocco in 1983?
Ensure brevity in your answer.  -11.96. What is the difference between the Pupil-teacher ratio(headcount basis) of Caribbean small states in 1982 and the Pupil-teacher ratio(headcount basis) of Bermuda in 1983?
Make the answer very short. 12.08. What is the difference between the Pupil-teacher ratio(headcount basis) of Caribbean small states in 1982 and the Pupil-teacher ratio(headcount basis) of Greece in 1983?
Your answer should be compact. 6.07. What is the difference between the Pupil-teacher ratio(headcount basis) in Caribbean small states in 1982 and the Pupil-teacher ratio(headcount basis) in Morocco in 1983?
Keep it short and to the point. -6.16. What is the difference between the Pupil-teacher ratio(headcount basis) in Bermuda in 1982 and the Pupil-teacher ratio(headcount basis) in Greece in 1983?
Ensure brevity in your answer.  -5.82. What is the difference between the Pupil-teacher ratio(headcount basis) of Bermuda in 1982 and the Pupil-teacher ratio(headcount basis) of Morocco in 1983?
Give a very brief answer. -18.05. What is the difference between the Pupil-teacher ratio(headcount basis) of Greece in 1982 and the Pupil-teacher ratio(headcount basis) of Morocco in 1983?
Give a very brief answer. -12.6. What is the average Pupil-teacher ratio(headcount basis) of Caribbean small states per year?
Provide a short and direct response. 31.37. What is the average Pupil-teacher ratio(headcount basis) of Bermuda per year?
Provide a succinct answer. 20.1. What is the average Pupil-teacher ratio(headcount basis) of Greece per year?
Your answer should be very brief. 27.14. What is the average Pupil-teacher ratio(headcount basis) in Morocco per year?
Keep it short and to the point. 36.52. In the year 1973, what is the difference between the Pupil-teacher ratio(headcount basis) of Caribbean small states and Pupil-teacher ratio(headcount basis) of Bermuda?
Ensure brevity in your answer.  12.85. In the year 1973, what is the difference between the Pupil-teacher ratio(headcount basis) in Caribbean small states and Pupil-teacher ratio(headcount basis) in Greece?
Your answer should be compact. 1.51. In the year 1973, what is the difference between the Pupil-teacher ratio(headcount basis) of Caribbean small states and Pupil-teacher ratio(headcount basis) of Morocco?
Ensure brevity in your answer.  -1.26. In the year 1973, what is the difference between the Pupil-teacher ratio(headcount basis) in Bermuda and Pupil-teacher ratio(headcount basis) in Greece?
Your response must be concise. -11.34. In the year 1973, what is the difference between the Pupil-teacher ratio(headcount basis) in Bermuda and Pupil-teacher ratio(headcount basis) in Morocco?
Provide a succinct answer. -14.11. In the year 1973, what is the difference between the Pupil-teacher ratio(headcount basis) in Greece and Pupil-teacher ratio(headcount basis) in Morocco?
Provide a short and direct response. -2.77. In the year 1974, what is the difference between the Pupil-teacher ratio(headcount basis) in Caribbean small states and Pupil-teacher ratio(headcount basis) in Bermuda?
Give a very brief answer. 12.72. In the year 1974, what is the difference between the Pupil-teacher ratio(headcount basis) in Caribbean small states and Pupil-teacher ratio(headcount basis) in Greece?
Keep it short and to the point. 2.5. In the year 1974, what is the difference between the Pupil-teacher ratio(headcount basis) of Caribbean small states and Pupil-teacher ratio(headcount basis) of Morocco?
Your answer should be compact. -2.12. In the year 1974, what is the difference between the Pupil-teacher ratio(headcount basis) in Bermuda and Pupil-teacher ratio(headcount basis) in Greece?
Provide a succinct answer. -10.21. In the year 1974, what is the difference between the Pupil-teacher ratio(headcount basis) of Bermuda and Pupil-teacher ratio(headcount basis) of Morocco?
Keep it short and to the point. -14.83. In the year 1974, what is the difference between the Pupil-teacher ratio(headcount basis) of Greece and Pupil-teacher ratio(headcount basis) of Morocco?
Your answer should be compact. -4.62. In the year 1975, what is the difference between the Pupil-teacher ratio(headcount basis) in Caribbean small states and Pupil-teacher ratio(headcount basis) in Bermuda?
Keep it short and to the point. 11.46. In the year 1975, what is the difference between the Pupil-teacher ratio(headcount basis) of Caribbean small states and Pupil-teacher ratio(headcount basis) of Greece?
Provide a succinct answer. 2.29. In the year 1975, what is the difference between the Pupil-teacher ratio(headcount basis) of Caribbean small states and Pupil-teacher ratio(headcount basis) of Morocco?
Give a very brief answer. -3.99. In the year 1975, what is the difference between the Pupil-teacher ratio(headcount basis) of Bermuda and Pupil-teacher ratio(headcount basis) of Greece?
Provide a succinct answer. -9.17. In the year 1975, what is the difference between the Pupil-teacher ratio(headcount basis) of Bermuda and Pupil-teacher ratio(headcount basis) of Morocco?
Provide a short and direct response. -15.45. In the year 1975, what is the difference between the Pupil-teacher ratio(headcount basis) of Greece and Pupil-teacher ratio(headcount basis) of Morocco?
Your answer should be very brief. -6.28. In the year 1980, what is the difference between the Pupil-teacher ratio(headcount basis) of Caribbean small states and Pupil-teacher ratio(headcount basis) of Bermuda?
Ensure brevity in your answer.  8.21. In the year 1980, what is the difference between the Pupil-teacher ratio(headcount basis) in Caribbean small states and Pupil-teacher ratio(headcount basis) in Greece?
Make the answer very short. 6.24. In the year 1980, what is the difference between the Pupil-teacher ratio(headcount basis) of Caribbean small states and Pupil-teacher ratio(headcount basis) of Morocco?
Provide a succinct answer. -6.69. In the year 1980, what is the difference between the Pupil-teacher ratio(headcount basis) of Bermuda and Pupil-teacher ratio(headcount basis) of Greece?
Offer a terse response. -1.97. In the year 1980, what is the difference between the Pupil-teacher ratio(headcount basis) of Bermuda and Pupil-teacher ratio(headcount basis) of Morocco?
Provide a succinct answer. -14.9. In the year 1980, what is the difference between the Pupil-teacher ratio(headcount basis) in Greece and Pupil-teacher ratio(headcount basis) in Morocco?
Your answer should be very brief. -12.93. In the year 1981, what is the difference between the Pupil-teacher ratio(headcount basis) in Caribbean small states and Pupil-teacher ratio(headcount basis) in Bermuda?
Your answer should be compact. 11.61. In the year 1981, what is the difference between the Pupil-teacher ratio(headcount basis) of Caribbean small states and Pupil-teacher ratio(headcount basis) of Greece?
Provide a short and direct response. 6.49. In the year 1981, what is the difference between the Pupil-teacher ratio(headcount basis) in Caribbean small states and Pupil-teacher ratio(headcount basis) in Morocco?
Keep it short and to the point. -7.54. In the year 1981, what is the difference between the Pupil-teacher ratio(headcount basis) of Bermuda and Pupil-teacher ratio(headcount basis) of Greece?
Provide a short and direct response. -5.12. In the year 1981, what is the difference between the Pupil-teacher ratio(headcount basis) in Bermuda and Pupil-teacher ratio(headcount basis) in Morocco?
Ensure brevity in your answer.  -19.15. In the year 1981, what is the difference between the Pupil-teacher ratio(headcount basis) in Greece and Pupil-teacher ratio(headcount basis) in Morocco?
Give a very brief answer. -14.04. In the year 1982, what is the difference between the Pupil-teacher ratio(headcount basis) of Caribbean small states and Pupil-teacher ratio(headcount basis) of Bermuda?
Offer a terse response. 11.89. In the year 1982, what is the difference between the Pupil-teacher ratio(headcount basis) of Caribbean small states and Pupil-teacher ratio(headcount basis) of Greece?
Offer a very short reply. 6.44. In the year 1982, what is the difference between the Pupil-teacher ratio(headcount basis) of Caribbean small states and Pupil-teacher ratio(headcount basis) of Morocco?
Your response must be concise. -6.34. In the year 1982, what is the difference between the Pupil-teacher ratio(headcount basis) of Bermuda and Pupil-teacher ratio(headcount basis) of Greece?
Keep it short and to the point. -5.45. In the year 1982, what is the difference between the Pupil-teacher ratio(headcount basis) of Bermuda and Pupil-teacher ratio(headcount basis) of Morocco?
Keep it short and to the point. -18.23. In the year 1982, what is the difference between the Pupil-teacher ratio(headcount basis) in Greece and Pupil-teacher ratio(headcount basis) in Morocco?
Make the answer very short. -12.78. In the year 1983, what is the difference between the Pupil-teacher ratio(headcount basis) in Caribbean small states and Pupil-teacher ratio(headcount basis) in Bermuda?
Offer a very short reply. 10.17. In the year 1983, what is the difference between the Pupil-teacher ratio(headcount basis) in Caribbean small states and Pupil-teacher ratio(headcount basis) in Greece?
Your answer should be very brief. 4.17. In the year 1983, what is the difference between the Pupil-teacher ratio(headcount basis) in Caribbean small states and Pupil-teacher ratio(headcount basis) in Morocco?
Give a very brief answer. -8.07. In the year 1983, what is the difference between the Pupil-teacher ratio(headcount basis) of Bermuda and Pupil-teacher ratio(headcount basis) of Greece?
Offer a very short reply. -6. In the year 1983, what is the difference between the Pupil-teacher ratio(headcount basis) in Bermuda and Pupil-teacher ratio(headcount basis) in Morocco?
Your answer should be very brief. -18.23. In the year 1983, what is the difference between the Pupil-teacher ratio(headcount basis) of Greece and Pupil-teacher ratio(headcount basis) of Morocco?
Your answer should be compact. -12.23. What is the ratio of the Pupil-teacher ratio(headcount basis) in Caribbean small states in 1973 to that in 1974?
Offer a very short reply. 1.01. What is the ratio of the Pupil-teacher ratio(headcount basis) of Bermuda in 1973 to that in 1974?
Offer a very short reply. 1.01. What is the ratio of the Pupil-teacher ratio(headcount basis) of Greece in 1973 to that in 1974?
Offer a terse response. 1.04. What is the ratio of the Pupil-teacher ratio(headcount basis) in Morocco in 1973 to that in 1974?
Your answer should be very brief. 0.98. What is the ratio of the Pupil-teacher ratio(headcount basis) in Caribbean small states in 1973 to that in 1975?
Offer a very short reply. 1.03. What is the ratio of the Pupil-teacher ratio(headcount basis) in Bermuda in 1973 to that in 1975?
Provide a short and direct response. 0.98. What is the ratio of the Pupil-teacher ratio(headcount basis) in Greece in 1973 to that in 1975?
Keep it short and to the point. 1.06. What is the ratio of the Pupil-teacher ratio(headcount basis) in Morocco in 1973 to that in 1975?
Make the answer very short. 0.95. What is the ratio of the Pupil-teacher ratio(headcount basis) in Caribbean small states in 1973 to that in 1980?
Your response must be concise. 1.09. What is the ratio of the Pupil-teacher ratio(headcount basis) of Bermuda in 1973 to that in 1980?
Ensure brevity in your answer.  0.91. What is the ratio of the Pupil-teacher ratio(headcount basis) of Greece in 1973 to that in 1980?
Your response must be concise. 1.3. What is the ratio of the Pupil-teacher ratio(headcount basis) in Morocco in 1973 to that in 1980?
Your answer should be very brief. 0.93. What is the ratio of the Pupil-teacher ratio(headcount basis) of Caribbean small states in 1973 to that in 1981?
Your response must be concise. 1.1. What is the ratio of the Pupil-teacher ratio(headcount basis) in Bermuda in 1973 to that in 1981?
Keep it short and to the point. 1.1. What is the ratio of the Pupil-teacher ratio(headcount basis) of Greece in 1973 to that in 1981?
Your answer should be very brief. 1.34. What is the ratio of the Pupil-teacher ratio(headcount basis) in Morocco in 1973 to that in 1981?
Ensure brevity in your answer.  0.92. What is the ratio of the Pupil-teacher ratio(headcount basis) in Caribbean small states in 1973 to that in 1982?
Your response must be concise. 1.13. What is the ratio of the Pupil-teacher ratio(headcount basis) of Bermuda in 1973 to that in 1982?
Provide a short and direct response. 1.16. What is the ratio of the Pupil-teacher ratio(headcount basis) in Greece in 1973 to that in 1982?
Provide a short and direct response. 1.37. What is the ratio of the Pupil-teacher ratio(headcount basis) in Morocco in 1973 to that in 1982?
Give a very brief answer. 0.97. What is the ratio of the Pupil-teacher ratio(headcount basis) in Caribbean small states in 1973 to that in 1983?
Make the answer very short. 1.2. What is the ratio of the Pupil-teacher ratio(headcount basis) of Bermuda in 1973 to that in 1983?
Provide a short and direct response. 1.17. What is the ratio of the Pupil-teacher ratio(headcount basis) in Greece in 1973 to that in 1983?
Offer a very short reply. 1.35. What is the ratio of the Pupil-teacher ratio(headcount basis) in Caribbean small states in 1974 to that in 1975?
Provide a short and direct response. 1.02. What is the ratio of the Pupil-teacher ratio(headcount basis) in Bermuda in 1974 to that in 1975?
Make the answer very short. 0.98. What is the ratio of the Pupil-teacher ratio(headcount basis) of Greece in 1974 to that in 1975?
Provide a short and direct response. 1.02. What is the ratio of the Pupil-teacher ratio(headcount basis) in Morocco in 1974 to that in 1975?
Provide a succinct answer. 0.97. What is the ratio of the Pupil-teacher ratio(headcount basis) of Caribbean small states in 1974 to that in 1980?
Keep it short and to the point. 1.08. What is the ratio of the Pupil-teacher ratio(headcount basis) of Bermuda in 1974 to that in 1980?
Keep it short and to the point. 0.91. What is the ratio of the Pupil-teacher ratio(headcount basis) in Greece in 1974 to that in 1980?
Your answer should be compact. 1.25. What is the ratio of the Pupil-teacher ratio(headcount basis) in Morocco in 1974 to that in 1980?
Make the answer very short. 0.94. What is the ratio of the Pupil-teacher ratio(headcount basis) of Caribbean small states in 1974 to that in 1981?
Offer a very short reply. 1.09. What is the ratio of the Pupil-teacher ratio(headcount basis) in Bermuda in 1974 to that in 1981?
Provide a short and direct response. 1.09. What is the ratio of the Pupil-teacher ratio(headcount basis) in Greece in 1974 to that in 1981?
Your answer should be very brief. 1.28. What is the ratio of the Pupil-teacher ratio(headcount basis) in Morocco in 1974 to that in 1981?
Make the answer very short. 0.93. What is the ratio of the Pupil-teacher ratio(headcount basis) of Caribbean small states in 1974 to that in 1982?
Provide a short and direct response. 1.12. What is the ratio of the Pupil-teacher ratio(headcount basis) of Bermuda in 1974 to that in 1982?
Provide a short and direct response. 1.15. What is the ratio of the Pupil-teacher ratio(headcount basis) in Greece in 1974 to that in 1982?
Make the answer very short. 1.32. What is the ratio of the Pupil-teacher ratio(headcount basis) in Morocco in 1974 to that in 1982?
Offer a terse response. 0.98. What is the ratio of the Pupil-teacher ratio(headcount basis) of Caribbean small states in 1974 to that in 1983?
Your answer should be compact. 1.19. What is the ratio of the Pupil-teacher ratio(headcount basis) of Bermuda in 1974 to that in 1983?
Your response must be concise. 1.16. What is the ratio of the Pupil-teacher ratio(headcount basis) of Greece in 1974 to that in 1983?
Your answer should be compact. 1.3. What is the ratio of the Pupil-teacher ratio(headcount basis) in Morocco in 1974 to that in 1983?
Your response must be concise. 0.99. What is the ratio of the Pupil-teacher ratio(headcount basis) of Caribbean small states in 1975 to that in 1980?
Ensure brevity in your answer.  1.05. What is the ratio of the Pupil-teacher ratio(headcount basis) in Bermuda in 1975 to that in 1980?
Provide a succinct answer. 0.93. What is the ratio of the Pupil-teacher ratio(headcount basis) in Greece in 1975 to that in 1980?
Ensure brevity in your answer.  1.23. What is the ratio of the Pupil-teacher ratio(headcount basis) in Morocco in 1975 to that in 1980?
Give a very brief answer. 0.97. What is the ratio of the Pupil-teacher ratio(headcount basis) in Caribbean small states in 1975 to that in 1981?
Offer a very short reply. 1.07. What is the ratio of the Pupil-teacher ratio(headcount basis) of Bermuda in 1975 to that in 1981?
Ensure brevity in your answer.  1.12. What is the ratio of the Pupil-teacher ratio(headcount basis) of Greece in 1975 to that in 1981?
Offer a very short reply. 1.26. What is the ratio of the Pupil-teacher ratio(headcount basis) of Morocco in 1975 to that in 1981?
Offer a terse response. 0.96. What is the ratio of the Pupil-teacher ratio(headcount basis) in Caribbean small states in 1975 to that in 1982?
Your answer should be very brief. 1.09. What is the ratio of the Pupil-teacher ratio(headcount basis) in Bermuda in 1975 to that in 1982?
Ensure brevity in your answer.  1.18. What is the ratio of the Pupil-teacher ratio(headcount basis) in Greece in 1975 to that in 1982?
Your answer should be very brief. 1.3. What is the ratio of the Pupil-teacher ratio(headcount basis) in Morocco in 1975 to that in 1982?
Make the answer very short. 1.01. What is the ratio of the Pupil-teacher ratio(headcount basis) in Caribbean small states in 1975 to that in 1983?
Offer a very short reply. 1.17. What is the ratio of the Pupil-teacher ratio(headcount basis) of Bermuda in 1975 to that in 1983?
Make the answer very short. 1.19. What is the ratio of the Pupil-teacher ratio(headcount basis) of Greece in 1975 to that in 1983?
Keep it short and to the point. 1.28. What is the ratio of the Pupil-teacher ratio(headcount basis) of Caribbean small states in 1980 to that in 1981?
Ensure brevity in your answer.  1.01. What is the ratio of the Pupil-teacher ratio(headcount basis) in Bermuda in 1980 to that in 1981?
Provide a short and direct response. 1.2. What is the ratio of the Pupil-teacher ratio(headcount basis) in Greece in 1980 to that in 1981?
Provide a short and direct response. 1.03. What is the ratio of the Pupil-teacher ratio(headcount basis) in Caribbean small states in 1980 to that in 1982?
Your answer should be very brief. 1.04. What is the ratio of the Pupil-teacher ratio(headcount basis) in Bermuda in 1980 to that in 1982?
Keep it short and to the point. 1.27. What is the ratio of the Pupil-teacher ratio(headcount basis) of Greece in 1980 to that in 1982?
Your answer should be very brief. 1.06. What is the ratio of the Pupil-teacher ratio(headcount basis) in Morocco in 1980 to that in 1982?
Give a very brief answer. 1.04. What is the ratio of the Pupil-teacher ratio(headcount basis) of Caribbean small states in 1980 to that in 1983?
Your answer should be compact. 1.11. What is the ratio of the Pupil-teacher ratio(headcount basis) in Bermuda in 1980 to that in 1983?
Make the answer very short. 1.28. What is the ratio of the Pupil-teacher ratio(headcount basis) of Greece in 1980 to that in 1983?
Make the answer very short. 1.04. What is the ratio of the Pupil-teacher ratio(headcount basis) of Morocco in 1980 to that in 1983?
Provide a short and direct response. 1.05. What is the ratio of the Pupil-teacher ratio(headcount basis) in Caribbean small states in 1981 to that in 1982?
Give a very brief answer. 1.02. What is the ratio of the Pupil-teacher ratio(headcount basis) of Bermuda in 1981 to that in 1982?
Keep it short and to the point. 1.05. What is the ratio of the Pupil-teacher ratio(headcount basis) in Greece in 1981 to that in 1982?
Offer a terse response. 1.03. What is the ratio of the Pupil-teacher ratio(headcount basis) in Morocco in 1981 to that in 1982?
Your answer should be very brief. 1.05. What is the ratio of the Pupil-teacher ratio(headcount basis) of Caribbean small states in 1981 to that in 1983?
Offer a terse response. 1.09. What is the ratio of the Pupil-teacher ratio(headcount basis) in Bermuda in 1981 to that in 1983?
Ensure brevity in your answer.  1.07. What is the ratio of the Pupil-teacher ratio(headcount basis) in Greece in 1981 to that in 1983?
Ensure brevity in your answer.  1.01. What is the ratio of the Pupil-teacher ratio(headcount basis) in Morocco in 1981 to that in 1983?
Your response must be concise. 1.06. What is the ratio of the Pupil-teacher ratio(headcount basis) in Caribbean small states in 1982 to that in 1983?
Your answer should be compact. 1.07. What is the ratio of the Pupil-teacher ratio(headcount basis) of Bermuda in 1982 to that in 1983?
Your answer should be compact. 1.01. What is the ratio of the Pupil-teacher ratio(headcount basis) of Greece in 1982 to that in 1983?
Provide a short and direct response. 0.98. What is the ratio of the Pupil-teacher ratio(headcount basis) of Morocco in 1982 to that in 1983?
Your answer should be compact. 1. What is the difference between the highest and the second highest Pupil-teacher ratio(headcount basis) in Caribbean small states?
Offer a very short reply. 0.27. What is the difference between the highest and the second highest Pupil-teacher ratio(headcount basis) in Bermuda?
Your answer should be compact. 1.56. What is the difference between the highest and the second highest Pupil-teacher ratio(headcount basis) of Greece?
Offer a terse response. 1.26. What is the difference between the highest and the second highest Pupil-teacher ratio(headcount basis) in Morocco?
Your answer should be compact. 0.43. What is the difference between the highest and the lowest Pupil-teacher ratio(headcount basis) of Caribbean small states?
Your answer should be compact. 5.73. What is the difference between the highest and the lowest Pupil-teacher ratio(headcount basis) in Bermuda?
Your answer should be very brief. 4.99. What is the difference between the highest and the lowest Pupil-teacher ratio(headcount basis) in Greece?
Ensure brevity in your answer.  8.74. What is the difference between the highest and the lowest Pupil-teacher ratio(headcount basis) of Morocco?
Your answer should be compact. 3.17. 